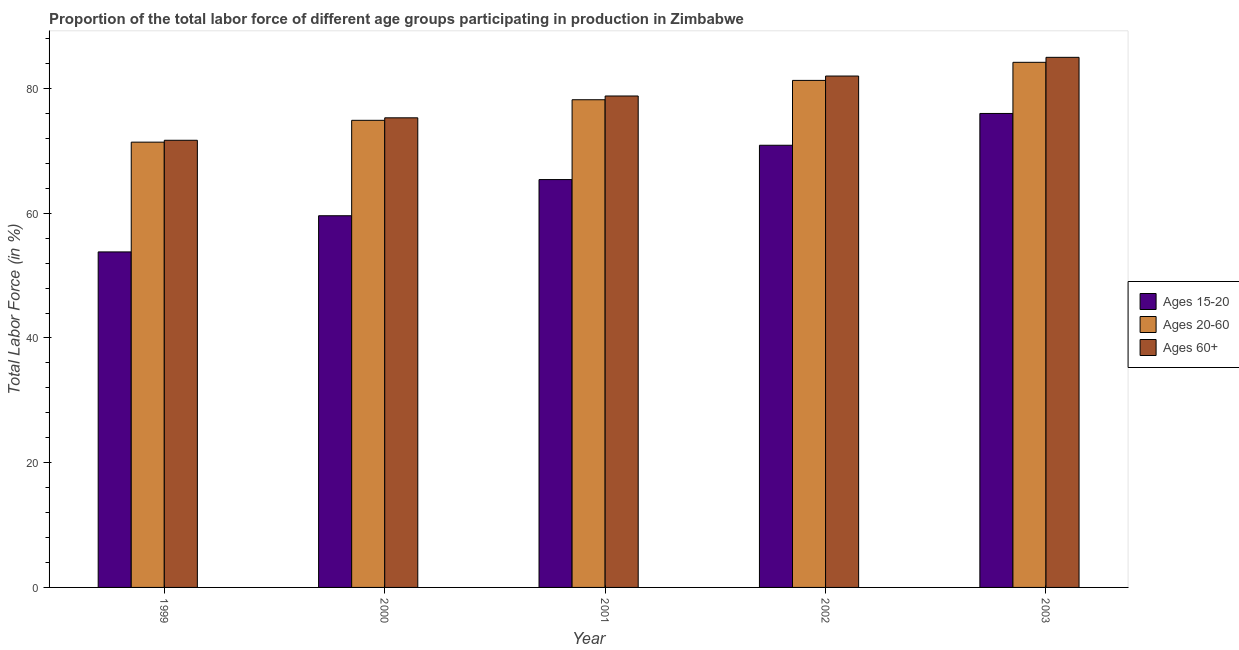How many different coloured bars are there?
Your answer should be compact. 3. Are the number of bars per tick equal to the number of legend labels?
Ensure brevity in your answer.  Yes. How many bars are there on the 4th tick from the left?
Your answer should be very brief. 3. What is the label of the 4th group of bars from the left?
Your answer should be compact. 2002. What is the percentage of labor force within the age group 15-20 in 2000?
Provide a succinct answer. 59.6. Across all years, what is the maximum percentage of labor force above age 60?
Offer a terse response. 85. Across all years, what is the minimum percentage of labor force within the age group 20-60?
Provide a succinct answer. 71.4. In which year was the percentage of labor force above age 60 maximum?
Provide a short and direct response. 2003. In which year was the percentage of labor force within the age group 20-60 minimum?
Ensure brevity in your answer.  1999. What is the total percentage of labor force within the age group 15-20 in the graph?
Give a very brief answer. 325.7. What is the difference between the percentage of labor force within the age group 15-20 in 2000 and that in 2002?
Your answer should be very brief. -11.3. What is the difference between the percentage of labor force within the age group 20-60 in 1999 and the percentage of labor force within the age group 15-20 in 2002?
Keep it short and to the point. -9.9. What is the ratio of the percentage of labor force within the age group 15-20 in 1999 to that in 2001?
Your answer should be compact. 0.82. Is the percentage of labor force above age 60 in 2000 less than that in 2003?
Provide a succinct answer. Yes. Is the difference between the percentage of labor force within the age group 20-60 in 2000 and 2002 greater than the difference between the percentage of labor force within the age group 15-20 in 2000 and 2002?
Your answer should be compact. No. What is the difference between the highest and the second highest percentage of labor force within the age group 15-20?
Keep it short and to the point. 5.1. What is the difference between the highest and the lowest percentage of labor force within the age group 20-60?
Your answer should be very brief. 12.8. Is the sum of the percentage of labor force within the age group 20-60 in 1999 and 2003 greater than the maximum percentage of labor force within the age group 15-20 across all years?
Give a very brief answer. Yes. What does the 3rd bar from the left in 2001 represents?
Make the answer very short. Ages 60+. What does the 1st bar from the right in 1999 represents?
Ensure brevity in your answer.  Ages 60+. How many bars are there?
Offer a very short reply. 15. Are all the bars in the graph horizontal?
Your response must be concise. No. How many years are there in the graph?
Give a very brief answer. 5. Does the graph contain any zero values?
Your response must be concise. No. Does the graph contain grids?
Offer a terse response. No. How are the legend labels stacked?
Give a very brief answer. Vertical. What is the title of the graph?
Make the answer very short. Proportion of the total labor force of different age groups participating in production in Zimbabwe. Does "Ages 50+" appear as one of the legend labels in the graph?
Your answer should be compact. No. What is the label or title of the X-axis?
Offer a terse response. Year. What is the Total Labor Force (in %) in Ages 15-20 in 1999?
Offer a very short reply. 53.8. What is the Total Labor Force (in %) of Ages 20-60 in 1999?
Make the answer very short. 71.4. What is the Total Labor Force (in %) in Ages 60+ in 1999?
Keep it short and to the point. 71.7. What is the Total Labor Force (in %) in Ages 15-20 in 2000?
Your answer should be very brief. 59.6. What is the Total Labor Force (in %) in Ages 20-60 in 2000?
Make the answer very short. 74.9. What is the Total Labor Force (in %) in Ages 60+ in 2000?
Your answer should be very brief. 75.3. What is the Total Labor Force (in %) of Ages 15-20 in 2001?
Give a very brief answer. 65.4. What is the Total Labor Force (in %) in Ages 20-60 in 2001?
Your answer should be very brief. 78.2. What is the Total Labor Force (in %) in Ages 60+ in 2001?
Your answer should be very brief. 78.8. What is the Total Labor Force (in %) of Ages 15-20 in 2002?
Give a very brief answer. 70.9. What is the Total Labor Force (in %) in Ages 20-60 in 2002?
Your response must be concise. 81.3. What is the Total Labor Force (in %) in Ages 20-60 in 2003?
Your answer should be compact. 84.2. What is the Total Labor Force (in %) of Ages 60+ in 2003?
Make the answer very short. 85. Across all years, what is the maximum Total Labor Force (in %) in Ages 15-20?
Make the answer very short. 76. Across all years, what is the maximum Total Labor Force (in %) of Ages 20-60?
Provide a short and direct response. 84.2. Across all years, what is the minimum Total Labor Force (in %) in Ages 15-20?
Your answer should be compact. 53.8. Across all years, what is the minimum Total Labor Force (in %) in Ages 20-60?
Keep it short and to the point. 71.4. Across all years, what is the minimum Total Labor Force (in %) in Ages 60+?
Ensure brevity in your answer.  71.7. What is the total Total Labor Force (in %) of Ages 15-20 in the graph?
Make the answer very short. 325.7. What is the total Total Labor Force (in %) of Ages 20-60 in the graph?
Give a very brief answer. 390. What is the total Total Labor Force (in %) in Ages 60+ in the graph?
Your answer should be very brief. 392.8. What is the difference between the Total Labor Force (in %) of Ages 15-20 in 1999 and that in 2000?
Give a very brief answer. -5.8. What is the difference between the Total Labor Force (in %) of Ages 20-60 in 1999 and that in 2000?
Provide a succinct answer. -3.5. What is the difference between the Total Labor Force (in %) of Ages 60+ in 1999 and that in 2000?
Provide a short and direct response. -3.6. What is the difference between the Total Labor Force (in %) of Ages 60+ in 1999 and that in 2001?
Offer a very short reply. -7.1. What is the difference between the Total Labor Force (in %) of Ages 15-20 in 1999 and that in 2002?
Offer a very short reply. -17.1. What is the difference between the Total Labor Force (in %) of Ages 60+ in 1999 and that in 2002?
Offer a very short reply. -10.3. What is the difference between the Total Labor Force (in %) of Ages 15-20 in 1999 and that in 2003?
Your response must be concise. -22.2. What is the difference between the Total Labor Force (in %) in Ages 20-60 in 2000 and that in 2001?
Offer a very short reply. -3.3. What is the difference between the Total Labor Force (in %) in Ages 60+ in 2000 and that in 2001?
Your response must be concise. -3.5. What is the difference between the Total Labor Force (in %) in Ages 15-20 in 2000 and that in 2003?
Your response must be concise. -16.4. What is the difference between the Total Labor Force (in %) of Ages 20-60 in 2000 and that in 2003?
Offer a terse response. -9.3. What is the difference between the Total Labor Force (in %) in Ages 60+ in 2000 and that in 2003?
Your answer should be compact. -9.7. What is the difference between the Total Labor Force (in %) in Ages 20-60 in 2001 and that in 2002?
Your answer should be compact. -3.1. What is the difference between the Total Labor Force (in %) of Ages 60+ in 2001 and that in 2002?
Your answer should be very brief. -3.2. What is the difference between the Total Labor Force (in %) in Ages 15-20 in 2002 and that in 2003?
Offer a terse response. -5.1. What is the difference between the Total Labor Force (in %) of Ages 60+ in 2002 and that in 2003?
Your response must be concise. -3. What is the difference between the Total Labor Force (in %) in Ages 15-20 in 1999 and the Total Labor Force (in %) in Ages 20-60 in 2000?
Your answer should be very brief. -21.1. What is the difference between the Total Labor Force (in %) of Ages 15-20 in 1999 and the Total Labor Force (in %) of Ages 60+ in 2000?
Provide a short and direct response. -21.5. What is the difference between the Total Labor Force (in %) in Ages 20-60 in 1999 and the Total Labor Force (in %) in Ages 60+ in 2000?
Keep it short and to the point. -3.9. What is the difference between the Total Labor Force (in %) in Ages 15-20 in 1999 and the Total Labor Force (in %) in Ages 20-60 in 2001?
Your response must be concise. -24.4. What is the difference between the Total Labor Force (in %) of Ages 20-60 in 1999 and the Total Labor Force (in %) of Ages 60+ in 2001?
Offer a terse response. -7.4. What is the difference between the Total Labor Force (in %) in Ages 15-20 in 1999 and the Total Labor Force (in %) in Ages 20-60 in 2002?
Make the answer very short. -27.5. What is the difference between the Total Labor Force (in %) in Ages 15-20 in 1999 and the Total Labor Force (in %) in Ages 60+ in 2002?
Keep it short and to the point. -28.2. What is the difference between the Total Labor Force (in %) in Ages 20-60 in 1999 and the Total Labor Force (in %) in Ages 60+ in 2002?
Make the answer very short. -10.6. What is the difference between the Total Labor Force (in %) in Ages 15-20 in 1999 and the Total Labor Force (in %) in Ages 20-60 in 2003?
Give a very brief answer. -30.4. What is the difference between the Total Labor Force (in %) of Ages 15-20 in 1999 and the Total Labor Force (in %) of Ages 60+ in 2003?
Provide a short and direct response. -31.2. What is the difference between the Total Labor Force (in %) in Ages 15-20 in 2000 and the Total Labor Force (in %) in Ages 20-60 in 2001?
Keep it short and to the point. -18.6. What is the difference between the Total Labor Force (in %) in Ages 15-20 in 2000 and the Total Labor Force (in %) in Ages 60+ in 2001?
Provide a short and direct response. -19.2. What is the difference between the Total Labor Force (in %) of Ages 20-60 in 2000 and the Total Labor Force (in %) of Ages 60+ in 2001?
Offer a terse response. -3.9. What is the difference between the Total Labor Force (in %) of Ages 15-20 in 2000 and the Total Labor Force (in %) of Ages 20-60 in 2002?
Offer a very short reply. -21.7. What is the difference between the Total Labor Force (in %) in Ages 15-20 in 2000 and the Total Labor Force (in %) in Ages 60+ in 2002?
Ensure brevity in your answer.  -22.4. What is the difference between the Total Labor Force (in %) of Ages 15-20 in 2000 and the Total Labor Force (in %) of Ages 20-60 in 2003?
Your response must be concise. -24.6. What is the difference between the Total Labor Force (in %) of Ages 15-20 in 2000 and the Total Labor Force (in %) of Ages 60+ in 2003?
Provide a succinct answer. -25.4. What is the difference between the Total Labor Force (in %) in Ages 20-60 in 2000 and the Total Labor Force (in %) in Ages 60+ in 2003?
Make the answer very short. -10.1. What is the difference between the Total Labor Force (in %) in Ages 15-20 in 2001 and the Total Labor Force (in %) in Ages 20-60 in 2002?
Offer a very short reply. -15.9. What is the difference between the Total Labor Force (in %) of Ages 15-20 in 2001 and the Total Labor Force (in %) of Ages 60+ in 2002?
Offer a very short reply. -16.6. What is the difference between the Total Labor Force (in %) in Ages 15-20 in 2001 and the Total Labor Force (in %) in Ages 20-60 in 2003?
Give a very brief answer. -18.8. What is the difference between the Total Labor Force (in %) of Ages 15-20 in 2001 and the Total Labor Force (in %) of Ages 60+ in 2003?
Keep it short and to the point. -19.6. What is the difference between the Total Labor Force (in %) in Ages 15-20 in 2002 and the Total Labor Force (in %) in Ages 20-60 in 2003?
Ensure brevity in your answer.  -13.3. What is the difference between the Total Labor Force (in %) in Ages 15-20 in 2002 and the Total Labor Force (in %) in Ages 60+ in 2003?
Offer a terse response. -14.1. What is the difference between the Total Labor Force (in %) of Ages 20-60 in 2002 and the Total Labor Force (in %) of Ages 60+ in 2003?
Make the answer very short. -3.7. What is the average Total Labor Force (in %) of Ages 15-20 per year?
Provide a succinct answer. 65.14. What is the average Total Labor Force (in %) in Ages 20-60 per year?
Offer a very short reply. 78. What is the average Total Labor Force (in %) of Ages 60+ per year?
Your response must be concise. 78.56. In the year 1999, what is the difference between the Total Labor Force (in %) of Ages 15-20 and Total Labor Force (in %) of Ages 20-60?
Your answer should be compact. -17.6. In the year 1999, what is the difference between the Total Labor Force (in %) of Ages 15-20 and Total Labor Force (in %) of Ages 60+?
Your answer should be compact. -17.9. In the year 1999, what is the difference between the Total Labor Force (in %) of Ages 20-60 and Total Labor Force (in %) of Ages 60+?
Provide a succinct answer. -0.3. In the year 2000, what is the difference between the Total Labor Force (in %) in Ages 15-20 and Total Labor Force (in %) in Ages 20-60?
Provide a succinct answer. -15.3. In the year 2000, what is the difference between the Total Labor Force (in %) of Ages 15-20 and Total Labor Force (in %) of Ages 60+?
Ensure brevity in your answer.  -15.7. In the year 2000, what is the difference between the Total Labor Force (in %) in Ages 20-60 and Total Labor Force (in %) in Ages 60+?
Keep it short and to the point. -0.4. In the year 2001, what is the difference between the Total Labor Force (in %) in Ages 20-60 and Total Labor Force (in %) in Ages 60+?
Your answer should be very brief. -0.6. In the year 2002, what is the difference between the Total Labor Force (in %) in Ages 15-20 and Total Labor Force (in %) in Ages 20-60?
Give a very brief answer. -10.4. In the year 2002, what is the difference between the Total Labor Force (in %) of Ages 15-20 and Total Labor Force (in %) of Ages 60+?
Offer a terse response. -11.1. In the year 2002, what is the difference between the Total Labor Force (in %) in Ages 20-60 and Total Labor Force (in %) in Ages 60+?
Your answer should be compact. -0.7. In the year 2003, what is the difference between the Total Labor Force (in %) in Ages 15-20 and Total Labor Force (in %) in Ages 60+?
Your answer should be compact. -9. What is the ratio of the Total Labor Force (in %) in Ages 15-20 in 1999 to that in 2000?
Provide a succinct answer. 0.9. What is the ratio of the Total Labor Force (in %) of Ages 20-60 in 1999 to that in 2000?
Provide a short and direct response. 0.95. What is the ratio of the Total Labor Force (in %) of Ages 60+ in 1999 to that in 2000?
Offer a terse response. 0.95. What is the ratio of the Total Labor Force (in %) of Ages 15-20 in 1999 to that in 2001?
Give a very brief answer. 0.82. What is the ratio of the Total Labor Force (in %) of Ages 20-60 in 1999 to that in 2001?
Provide a short and direct response. 0.91. What is the ratio of the Total Labor Force (in %) in Ages 60+ in 1999 to that in 2001?
Provide a succinct answer. 0.91. What is the ratio of the Total Labor Force (in %) in Ages 15-20 in 1999 to that in 2002?
Make the answer very short. 0.76. What is the ratio of the Total Labor Force (in %) in Ages 20-60 in 1999 to that in 2002?
Provide a succinct answer. 0.88. What is the ratio of the Total Labor Force (in %) of Ages 60+ in 1999 to that in 2002?
Keep it short and to the point. 0.87. What is the ratio of the Total Labor Force (in %) of Ages 15-20 in 1999 to that in 2003?
Offer a very short reply. 0.71. What is the ratio of the Total Labor Force (in %) of Ages 20-60 in 1999 to that in 2003?
Your answer should be very brief. 0.85. What is the ratio of the Total Labor Force (in %) in Ages 60+ in 1999 to that in 2003?
Your answer should be very brief. 0.84. What is the ratio of the Total Labor Force (in %) in Ages 15-20 in 2000 to that in 2001?
Offer a terse response. 0.91. What is the ratio of the Total Labor Force (in %) of Ages 20-60 in 2000 to that in 2001?
Provide a succinct answer. 0.96. What is the ratio of the Total Labor Force (in %) in Ages 60+ in 2000 to that in 2001?
Your response must be concise. 0.96. What is the ratio of the Total Labor Force (in %) of Ages 15-20 in 2000 to that in 2002?
Offer a terse response. 0.84. What is the ratio of the Total Labor Force (in %) in Ages 20-60 in 2000 to that in 2002?
Your response must be concise. 0.92. What is the ratio of the Total Labor Force (in %) of Ages 60+ in 2000 to that in 2002?
Offer a terse response. 0.92. What is the ratio of the Total Labor Force (in %) of Ages 15-20 in 2000 to that in 2003?
Your answer should be very brief. 0.78. What is the ratio of the Total Labor Force (in %) of Ages 20-60 in 2000 to that in 2003?
Make the answer very short. 0.89. What is the ratio of the Total Labor Force (in %) of Ages 60+ in 2000 to that in 2003?
Your response must be concise. 0.89. What is the ratio of the Total Labor Force (in %) in Ages 15-20 in 2001 to that in 2002?
Provide a short and direct response. 0.92. What is the ratio of the Total Labor Force (in %) of Ages 20-60 in 2001 to that in 2002?
Give a very brief answer. 0.96. What is the ratio of the Total Labor Force (in %) of Ages 15-20 in 2001 to that in 2003?
Make the answer very short. 0.86. What is the ratio of the Total Labor Force (in %) of Ages 20-60 in 2001 to that in 2003?
Ensure brevity in your answer.  0.93. What is the ratio of the Total Labor Force (in %) in Ages 60+ in 2001 to that in 2003?
Your answer should be compact. 0.93. What is the ratio of the Total Labor Force (in %) of Ages 15-20 in 2002 to that in 2003?
Your response must be concise. 0.93. What is the ratio of the Total Labor Force (in %) in Ages 20-60 in 2002 to that in 2003?
Your response must be concise. 0.97. What is the ratio of the Total Labor Force (in %) of Ages 60+ in 2002 to that in 2003?
Keep it short and to the point. 0.96. What is the difference between the highest and the second highest Total Labor Force (in %) in Ages 20-60?
Your answer should be compact. 2.9. What is the difference between the highest and the lowest Total Labor Force (in %) of Ages 15-20?
Keep it short and to the point. 22.2. What is the difference between the highest and the lowest Total Labor Force (in %) of Ages 20-60?
Your answer should be very brief. 12.8. 